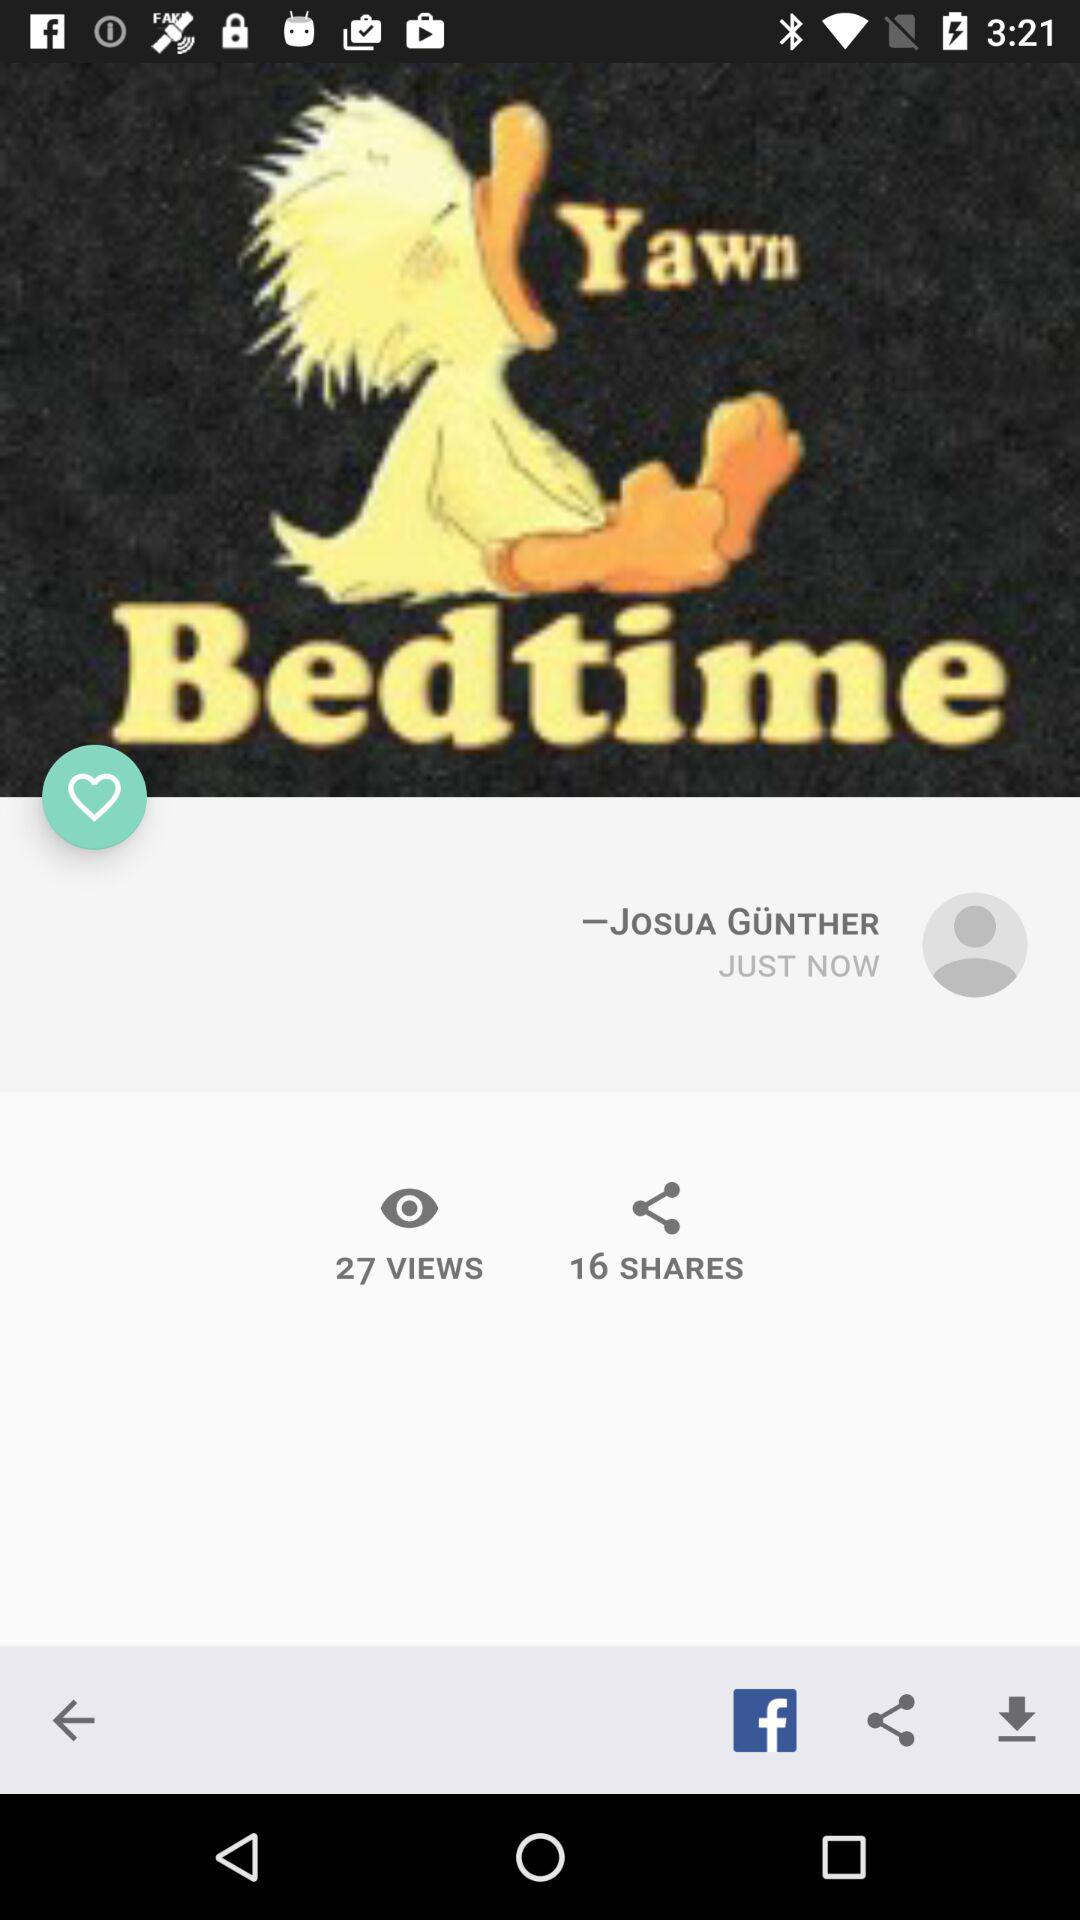Who is the writer? The writer is Josua Gunther. 